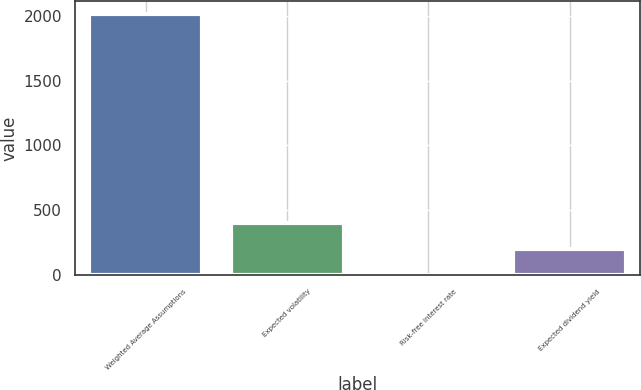<chart> <loc_0><loc_0><loc_500><loc_500><bar_chart><fcel>Weighted Average Assumptions<fcel>Expected volatility<fcel>Risk-free interest rate<fcel>Expected dividend yield<nl><fcel>2016<fcel>404.26<fcel>1.32<fcel>202.79<nl></chart> 